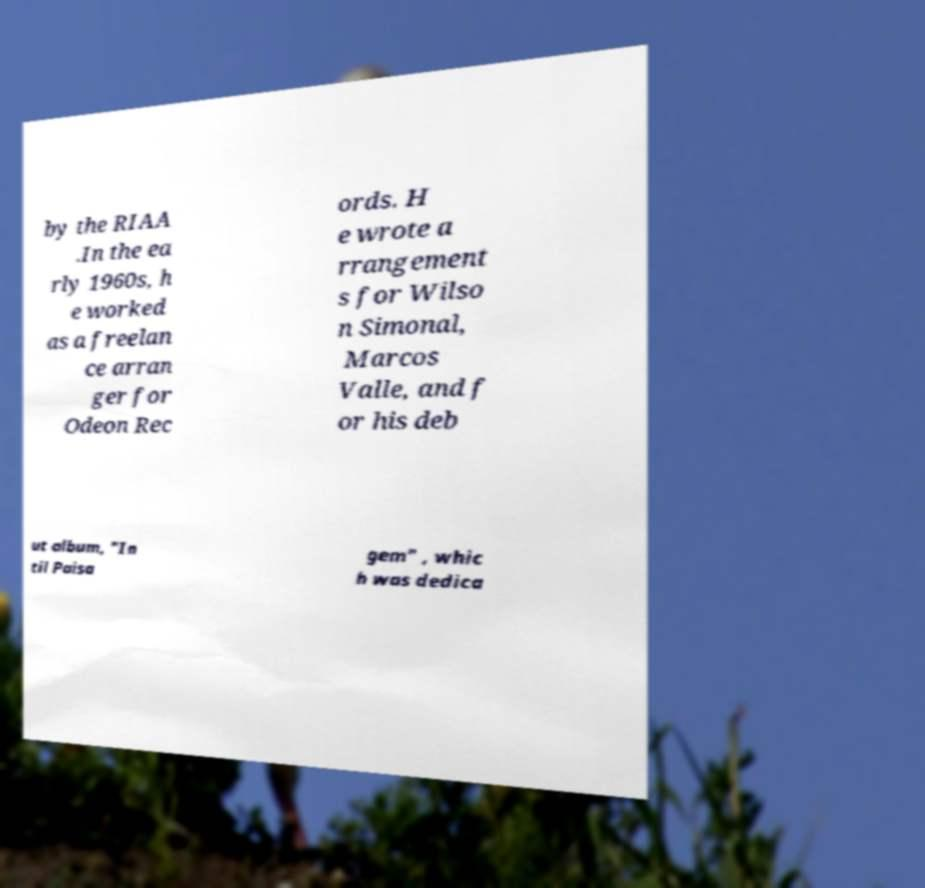I need the written content from this picture converted into text. Can you do that? by the RIAA .In the ea rly 1960s, h e worked as a freelan ce arran ger for Odeon Rec ords. H e wrote a rrangement s for Wilso n Simonal, Marcos Valle, and f or his deb ut album, "In til Paisa gem" , whic h was dedica 